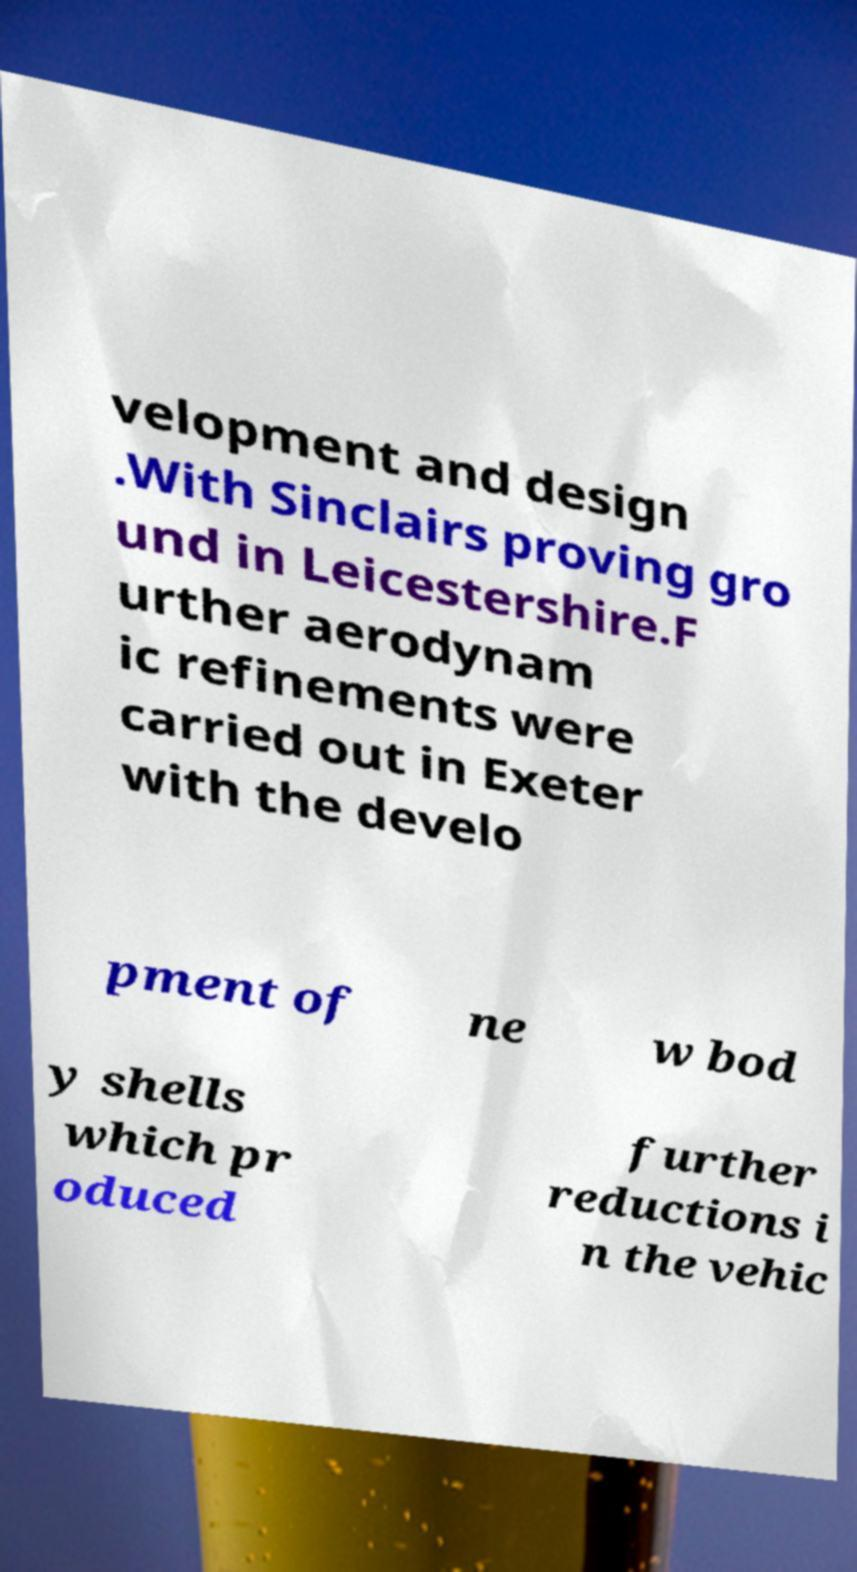For documentation purposes, I need the text within this image transcribed. Could you provide that? velopment and design .With Sinclairs proving gro und in Leicestershire.F urther aerodynam ic refinements were carried out in Exeter with the develo pment of ne w bod y shells which pr oduced further reductions i n the vehic 